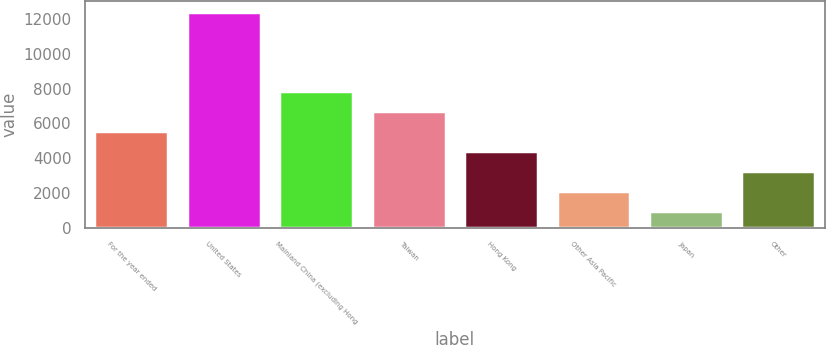<chart> <loc_0><loc_0><loc_500><loc_500><bar_chart><fcel>For the year ended<fcel>United States<fcel>Mainland China (excluding Hong<fcel>Taiwan<fcel>Hong Kong<fcel>Other Asia Pacific<fcel>Japan<fcel>Other<nl><fcel>5555.2<fcel>12451<fcel>7853.8<fcel>6704.5<fcel>4405.9<fcel>2107.3<fcel>958<fcel>3256.6<nl></chart> 